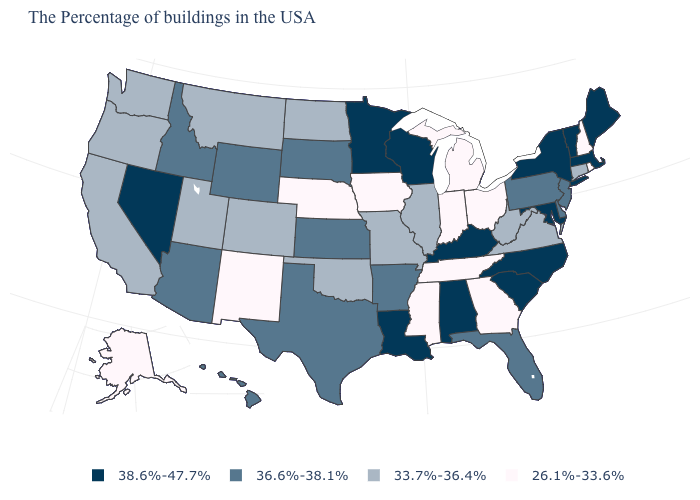What is the lowest value in the Northeast?
Keep it brief. 26.1%-33.6%. Is the legend a continuous bar?
Keep it brief. No. What is the value of Vermont?
Be succinct. 38.6%-47.7%. What is the value of Wisconsin?
Answer briefly. 38.6%-47.7%. Which states have the highest value in the USA?
Short answer required. Maine, Massachusetts, Vermont, New York, Maryland, North Carolina, South Carolina, Kentucky, Alabama, Wisconsin, Louisiana, Minnesota, Nevada. Is the legend a continuous bar?
Be succinct. No. Name the states that have a value in the range 26.1%-33.6%?
Keep it brief. Rhode Island, New Hampshire, Ohio, Georgia, Michigan, Indiana, Tennessee, Mississippi, Iowa, Nebraska, New Mexico, Alaska. Does Indiana have the lowest value in the USA?
Answer briefly. Yes. Does Massachusetts have a higher value than Hawaii?
Quick response, please. Yes. Name the states that have a value in the range 36.6%-38.1%?
Keep it brief. New Jersey, Delaware, Pennsylvania, Florida, Arkansas, Kansas, Texas, South Dakota, Wyoming, Arizona, Idaho, Hawaii. Which states have the lowest value in the Northeast?
Give a very brief answer. Rhode Island, New Hampshire. How many symbols are there in the legend?
Write a very short answer. 4. Does the map have missing data?
Short answer required. No. Name the states that have a value in the range 36.6%-38.1%?
Concise answer only. New Jersey, Delaware, Pennsylvania, Florida, Arkansas, Kansas, Texas, South Dakota, Wyoming, Arizona, Idaho, Hawaii. How many symbols are there in the legend?
Write a very short answer. 4. 